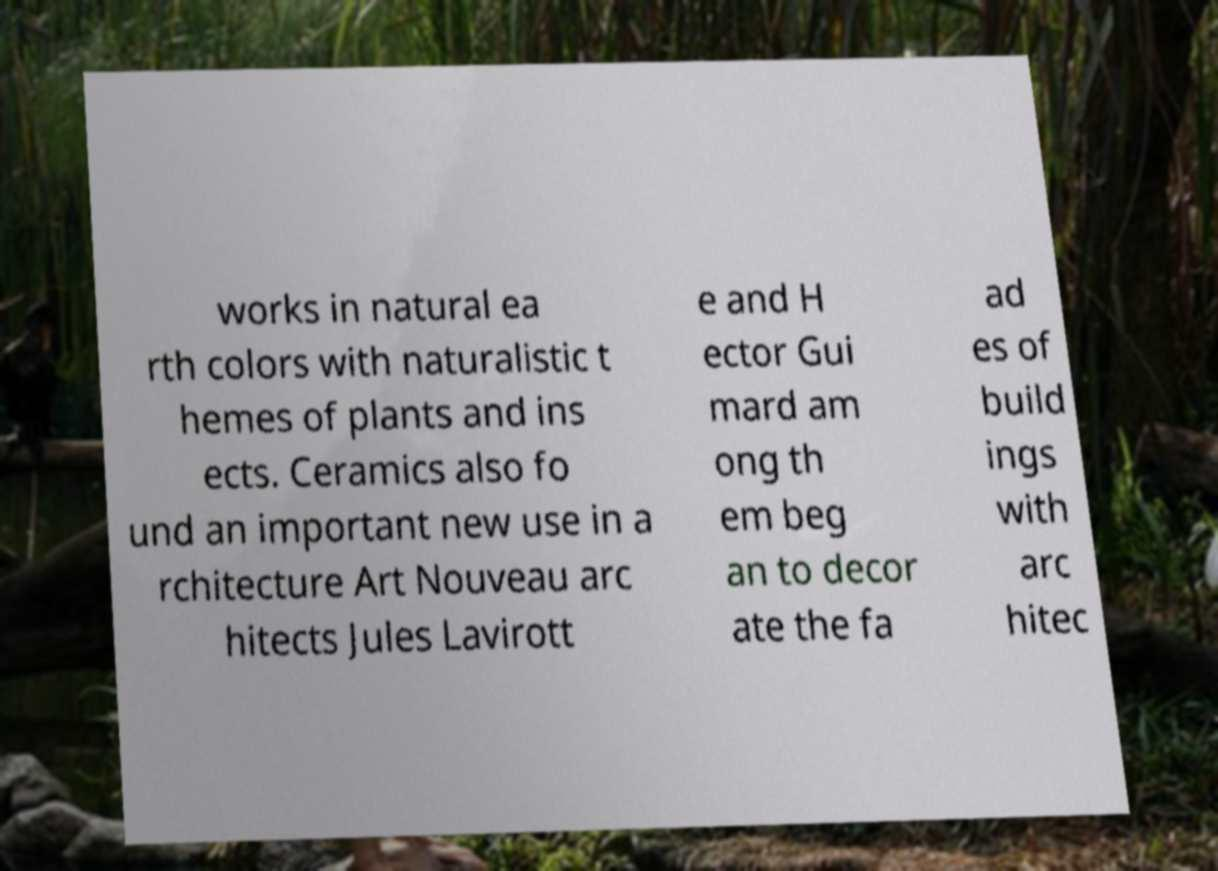Could you extract and type out the text from this image? works in natural ea rth colors with naturalistic t hemes of plants and ins ects. Ceramics also fo und an important new use in a rchitecture Art Nouveau arc hitects Jules Lavirott e and H ector Gui mard am ong th em beg an to decor ate the fa ad es of build ings with arc hitec 